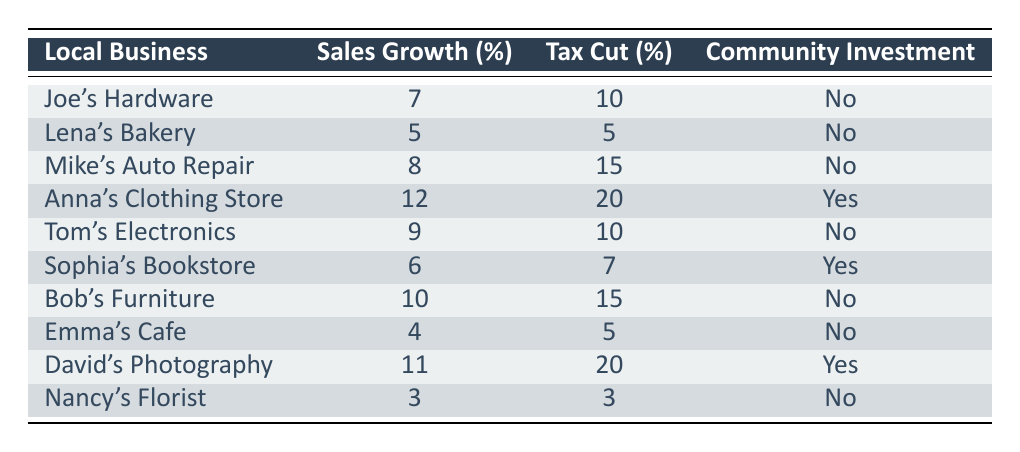What is the sales growth percentage for Joe's Hardware? The table shows that Joe's Hardware has a sales growth percentage listed. By referring directly to the row for Joe's Hardware, we see that it is 7%.
Answer: 7% Which local business received the highest tax cut percentage? The tax cut percentages for each business are compared: Joe's Hardware (10%), Lena's Bakery (5%), Mike's Auto Repair (15%), Anna's Clothing Store (20%), Tom's Electronics (10%), Sophia's Bookstore (7%), Bob's Furniture (15%), Emma's Cafe (5%), David's Photography (20%), and Nancy's Florist (3%). Anna's Clothing Store and David's Photography both received the highest tax cut percentage of 20%.
Answer: Anna's Clothing Store and David's Photography How many businesses made community investments? By reviewing the table, we note the community investment status for each business. We find that Anna's Clothing Store, Sophia's Bookstore, and David's Photography are the ones that made a community investment. Thus, there are 3 instances of community investment among the businesses.
Answer: 3 What is the average sales growth percentage of all businesses that did not invest in the community? First, we identify the businesses without community investments: Joe's Hardware (7%), Lena's Bakery (5%), Mike's Auto Repair (8%), Tom's Electronics (9%), Bob's Furniture (10%), Emma's Cafe (4%), and Nancy's Florist (3%). The sum of their sales growth percentages is: 7 + 5 + 8 + 9 + 10 + 4 + 3 = 46. There are 7 businesses, so the average is 46 / 7 ≈ 6.57%.
Answer: 6.57% Is there a direct correlation between tax cuts and sales growth among local businesses? By analyzing the data, we compare the sales growth percentages with the tax cut percentages for each business. While some businesses show a positive sales growth with higher tax cuts (e.g., Anna's Clothing Store and David's Photography), others do not follow this trend consistently. Thus, we cannot conclude there is a direct correlation without further analysis.
Answer: No, there isn't a direct correlation 